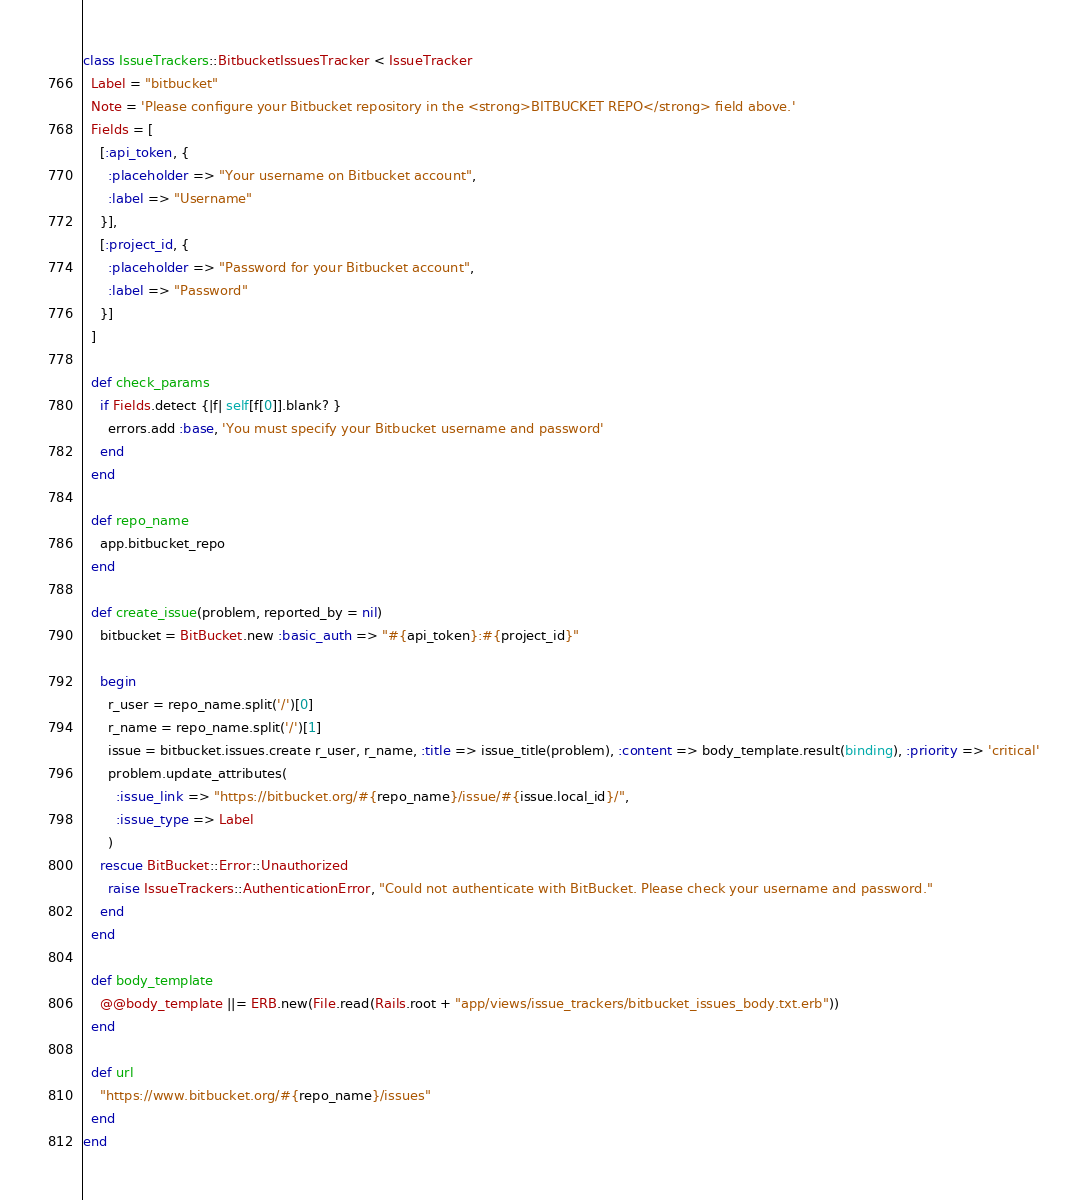<code> <loc_0><loc_0><loc_500><loc_500><_Ruby_>class IssueTrackers::BitbucketIssuesTracker < IssueTracker
  Label = "bitbucket"
  Note = 'Please configure your Bitbucket repository in the <strong>BITBUCKET REPO</strong> field above.'
  Fields = [
    [:api_token, {
      :placeholder => "Your username on Bitbucket account",
      :label => "Username"
    }],
    [:project_id, {
      :placeholder => "Password for your Bitbucket account",
      :label => "Password"
    }]
  ]

  def check_params
    if Fields.detect {|f| self[f[0]].blank? }
      errors.add :base, 'You must specify your Bitbucket username and password'
    end
  end

  def repo_name
    app.bitbucket_repo
  end

  def create_issue(problem, reported_by = nil)
    bitbucket = BitBucket.new :basic_auth => "#{api_token}:#{project_id}"

    begin
      r_user = repo_name.split('/')[0]
      r_name = repo_name.split('/')[1]
      issue = bitbucket.issues.create r_user, r_name, :title => issue_title(problem), :content => body_template.result(binding), :priority => 'critical'
      problem.update_attributes(
        :issue_link => "https://bitbucket.org/#{repo_name}/issue/#{issue.local_id}/",
        :issue_type => Label
      )
    rescue BitBucket::Error::Unauthorized
      raise IssueTrackers::AuthenticationError, "Could not authenticate with BitBucket. Please check your username and password."
    end
  end

  def body_template
    @@body_template ||= ERB.new(File.read(Rails.root + "app/views/issue_trackers/bitbucket_issues_body.txt.erb"))
  end

  def url
    "https://www.bitbucket.org/#{repo_name}/issues"
  end
end

</code> 